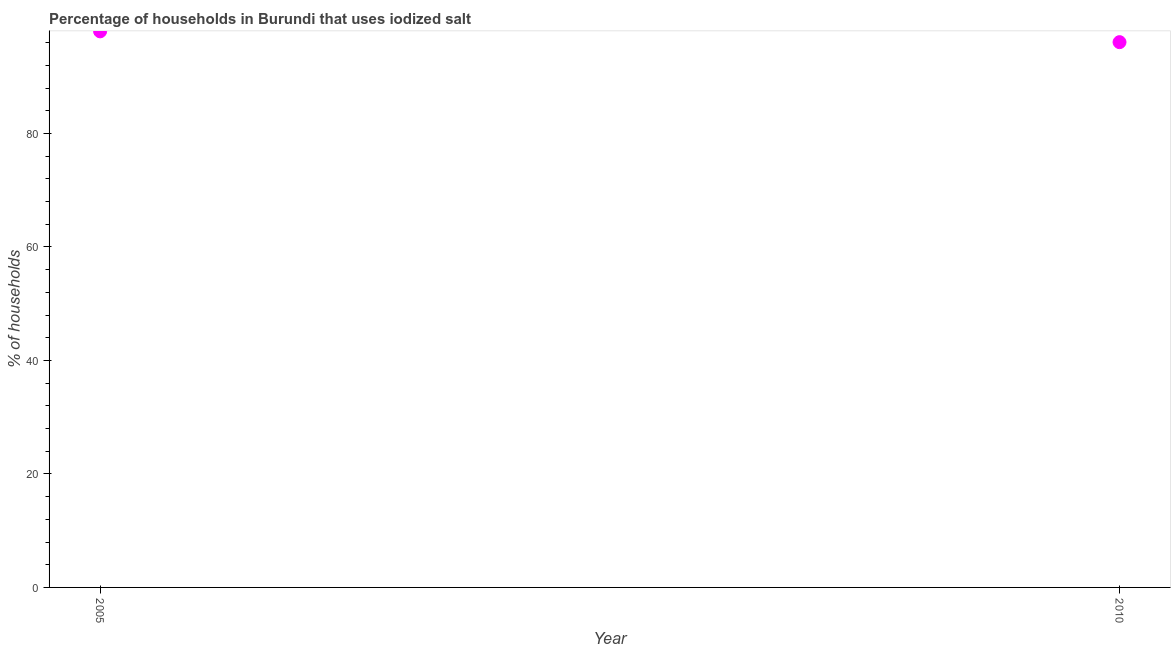Across all years, what is the maximum percentage of households where iodized salt is consumed?
Offer a very short reply. 98. Across all years, what is the minimum percentage of households where iodized salt is consumed?
Your answer should be very brief. 96.1. In which year was the percentage of households where iodized salt is consumed maximum?
Ensure brevity in your answer.  2005. In which year was the percentage of households where iodized salt is consumed minimum?
Your answer should be compact. 2010. What is the sum of the percentage of households where iodized salt is consumed?
Give a very brief answer. 194.1. What is the difference between the percentage of households where iodized salt is consumed in 2005 and 2010?
Provide a succinct answer. 1.9. What is the average percentage of households where iodized salt is consumed per year?
Provide a short and direct response. 97.05. What is the median percentage of households where iodized salt is consumed?
Your response must be concise. 97.05. In how many years, is the percentage of households where iodized salt is consumed greater than 20 %?
Provide a short and direct response. 2. What is the ratio of the percentage of households where iodized salt is consumed in 2005 to that in 2010?
Your answer should be very brief. 1.02. Is the percentage of households where iodized salt is consumed in 2005 less than that in 2010?
Provide a short and direct response. No. In how many years, is the percentage of households where iodized salt is consumed greater than the average percentage of households where iodized salt is consumed taken over all years?
Provide a succinct answer. 1. How many dotlines are there?
Ensure brevity in your answer.  1. What is the difference between two consecutive major ticks on the Y-axis?
Keep it short and to the point. 20. Are the values on the major ticks of Y-axis written in scientific E-notation?
Offer a terse response. No. Does the graph contain any zero values?
Offer a very short reply. No. What is the title of the graph?
Offer a terse response. Percentage of households in Burundi that uses iodized salt. What is the label or title of the Y-axis?
Ensure brevity in your answer.  % of households. What is the % of households in 2010?
Make the answer very short. 96.1. What is the ratio of the % of households in 2005 to that in 2010?
Your answer should be compact. 1.02. 